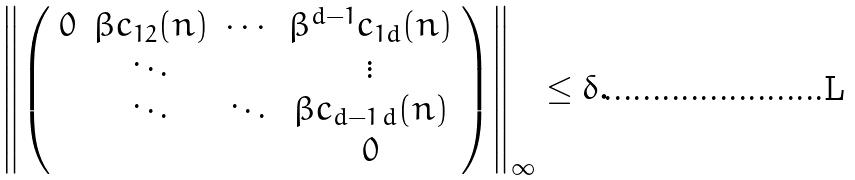<formula> <loc_0><loc_0><loc_500><loc_500>\left \| \left ( \begin{array} { c c c c } 0 & \beta c _ { 1 2 } ( n ) & \cdots & \beta ^ { d - 1 } c _ { 1 d } ( n ) \\ & \ddots & & \vdots \\ & \ddots & \ddots & \beta c _ { d - 1 \, d } ( n ) \\ & & & 0 \end{array} \right ) \right \| _ { \infty } \leq \delta .</formula> 